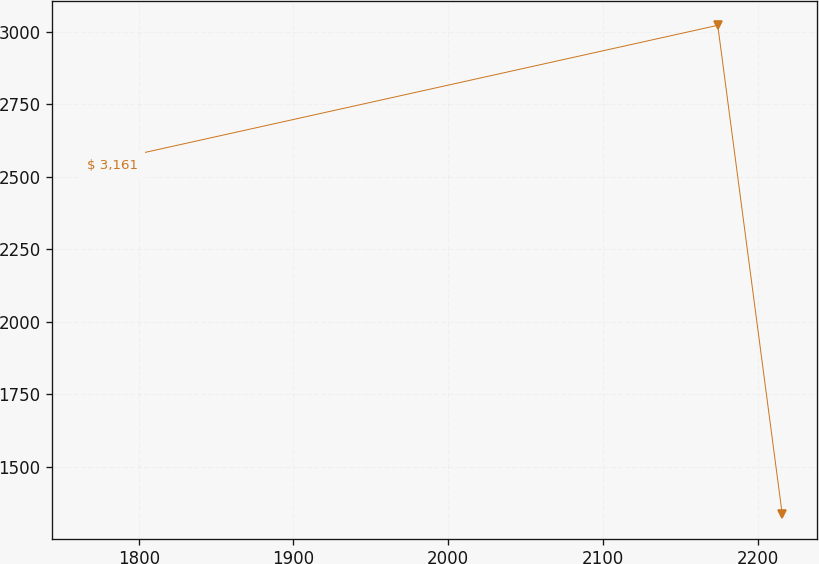Convert chart to OTSL. <chart><loc_0><loc_0><loc_500><loc_500><line_chart><ecel><fcel>$ 3,161<nl><fcel>1766.65<fcel>2539.29<nl><fcel>2174.27<fcel>3022<nl><fcel>2215.95<fcel>1335.68<nl></chart> 